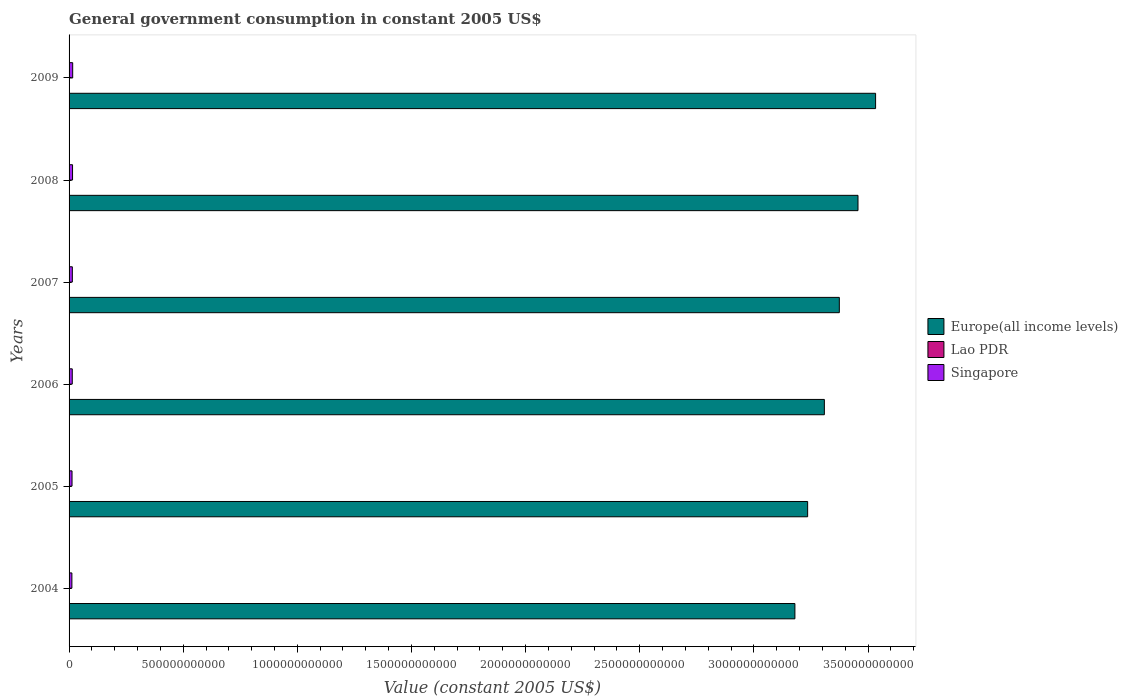Are the number of bars per tick equal to the number of legend labels?
Give a very brief answer. Yes. How many bars are there on the 2nd tick from the top?
Your answer should be compact. 3. What is the label of the 3rd group of bars from the top?
Offer a very short reply. 2007. What is the government conusmption in Europe(all income levels) in 2005?
Offer a terse response. 3.24e+12. Across all years, what is the maximum government conusmption in Europe(all income levels)?
Give a very brief answer. 3.53e+12. Across all years, what is the minimum government conusmption in Lao PDR?
Keep it short and to the point. 1.79e+08. What is the total government conusmption in Singapore in the graph?
Offer a terse response. 8.48e+1. What is the difference between the government conusmption in Lao PDR in 2008 and that in 2009?
Keep it short and to the point. -7.29e+07. What is the difference between the government conusmption in Lao PDR in 2006 and the government conusmption in Europe(all income levels) in 2009?
Your answer should be compact. -3.53e+12. What is the average government conusmption in Europe(all income levels) per year?
Ensure brevity in your answer.  3.35e+12. In the year 2004, what is the difference between the government conusmption in Europe(all income levels) and government conusmption in Lao PDR?
Your response must be concise. 3.18e+12. What is the ratio of the government conusmption in Lao PDR in 2005 to that in 2008?
Your answer should be compact. 0.68. What is the difference between the highest and the second highest government conusmption in Lao PDR?
Keep it short and to the point. 7.29e+07. What is the difference between the highest and the lowest government conusmption in Europe(all income levels)?
Keep it short and to the point. 3.53e+11. In how many years, is the government conusmption in Singapore greater than the average government conusmption in Singapore taken over all years?
Offer a very short reply. 3. Is the sum of the government conusmption in Europe(all income levels) in 2005 and 2006 greater than the maximum government conusmption in Lao PDR across all years?
Your response must be concise. Yes. What does the 2nd bar from the top in 2008 represents?
Your answer should be compact. Lao PDR. What does the 1st bar from the bottom in 2005 represents?
Make the answer very short. Europe(all income levels). Is it the case that in every year, the sum of the government conusmption in Singapore and government conusmption in Europe(all income levels) is greater than the government conusmption in Lao PDR?
Offer a terse response. Yes. How many bars are there?
Offer a very short reply. 18. What is the difference between two consecutive major ticks on the X-axis?
Give a very brief answer. 5.00e+11. Are the values on the major ticks of X-axis written in scientific E-notation?
Ensure brevity in your answer.  No. Where does the legend appear in the graph?
Provide a short and direct response. Center right. What is the title of the graph?
Provide a succinct answer. General government consumption in constant 2005 US$. Does "Croatia" appear as one of the legend labels in the graph?
Provide a short and direct response. No. What is the label or title of the X-axis?
Ensure brevity in your answer.  Value (constant 2005 US$). What is the label or title of the Y-axis?
Offer a terse response. Years. What is the Value (constant 2005 US$) of Europe(all income levels) in 2004?
Keep it short and to the point. 3.18e+12. What is the Value (constant 2005 US$) of Lao PDR in 2004?
Your answer should be very brief. 1.79e+08. What is the Value (constant 2005 US$) of Singapore in 2004?
Offer a terse response. 1.24e+1. What is the Value (constant 2005 US$) in Europe(all income levels) in 2005?
Provide a succinct answer. 3.24e+12. What is the Value (constant 2005 US$) in Lao PDR in 2005?
Your response must be concise. 2.22e+08. What is the Value (constant 2005 US$) in Singapore in 2005?
Provide a short and direct response. 1.30e+1. What is the Value (constant 2005 US$) of Europe(all income levels) in 2006?
Your response must be concise. 3.31e+12. What is the Value (constant 2005 US$) of Lao PDR in 2006?
Your answer should be very brief. 2.48e+08. What is the Value (constant 2005 US$) of Singapore in 2006?
Ensure brevity in your answer.  1.40e+1. What is the Value (constant 2005 US$) in Europe(all income levels) in 2007?
Your answer should be compact. 3.37e+12. What is the Value (constant 2005 US$) in Lao PDR in 2007?
Your answer should be very brief. 2.70e+08. What is the Value (constant 2005 US$) in Singapore in 2007?
Offer a very short reply. 1.44e+1. What is the Value (constant 2005 US$) in Europe(all income levels) in 2008?
Provide a succinct answer. 3.46e+12. What is the Value (constant 2005 US$) of Lao PDR in 2008?
Provide a succinct answer. 3.25e+08. What is the Value (constant 2005 US$) of Singapore in 2008?
Keep it short and to the point. 1.52e+1. What is the Value (constant 2005 US$) of Europe(all income levels) in 2009?
Your answer should be compact. 3.53e+12. What is the Value (constant 2005 US$) of Lao PDR in 2009?
Offer a very short reply. 3.98e+08. What is the Value (constant 2005 US$) of Singapore in 2009?
Ensure brevity in your answer.  1.59e+1. Across all years, what is the maximum Value (constant 2005 US$) of Europe(all income levels)?
Ensure brevity in your answer.  3.53e+12. Across all years, what is the maximum Value (constant 2005 US$) in Lao PDR?
Make the answer very short. 3.98e+08. Across all years, what is the maximum Value (constant 2005 US$) in Singapore?
Provide a short and direct response. 1.59e+1. Across all years, what is the minimum Value (constant 2005 US$) in Europe(all income levels)?
Keep it short and to the point. 3.18e+12. Across all years, what is the minimum Value (constant 2005 US$) in Lao PDR?
Give a very brief answer. 1.79e+08. Across all years, what is the minimum Value (constant 2005 US$) in Singapore?
Provide a succinct answer. 1.24e+1. What is the total Value (constant 2005 US$) of Europe(all income levels) in the graph?
Give a very brief answer. 2.01e+13. What is the total Value (constant 2005 US$) in Lao PDR in the graph?
Ensure brevity in your answer.  1.64e+09. What is the total Value (constant 2005 US$) in Singapore in the graph?
Make the answer very short. 8.48e+1. What is the difference between the Value (constant 2005 US$) of Europe(all income levels) in 2004 and that in 2005?
Keep it short and to the point. -5.58e+1. What is the difference between the Value (constant 2005 US$) of Lao PDR in 2004 and that in 2005?
Make the answer very short. -4.29e+07. What is the difference between the Value (constant 2005 US$) of Singapore in 2004 and that in 2005?
Ensure brevity in your answer.  -6.22e+08. What is the difference between the Value (constant 2005 US$) in Europe(all income levels) in 2004 and that in 2006?
Make the answer very short. -1.29e+11. What is the difference between the Value (constant 2005 US$) of Lao PDR in 2004 and that in 2006?
Provide a short and direct response. -6.93e+07. What is the difference between the Value (constant 2005 US$) of Singapore in 2004 and that in 2006?
Offer a terse response. -1.63e+09. What is the difference between the Value (constant 2005 US$) in Europe(all income levels) in 2004 and that in 2007?
Provide a succinct answer. -1.95e+11. What is the difference between the Value (constant 2005 US$) of Lao PDR in 2004 and that in 2007?
Provide a succinct answer. -9.17e+07. What is the difference between the Value (constant 2005 US$) in Singapore in 2004 and that in 2007?
Give a very brief answer. -2.01e+09. What is the difference between the Value (constant 2005 US$) of Europe(all income levels) in 2004 and that in 2008?
Your answer should be compact. -2.76e+11. What is the difference between the Value (constant 2005 US$) of Lao PDR in 2004 and that in 2008?
Ensure brevity in your answer.  -1.46e+08. What is the difference between the Value (constant 2005 US$) of Singapore in 2004 and that in 2008?
Make the answer very short. -2.86e+09. What is the difference between the Value (constant 2005 US$) in Europe(all income levels) in 2004 and that in 2009?
Give a very brief answer. -3.53e+11. What is the difference between the Value (constant 2005 US$) of Lao PDR in 2004 and that in 2009?
Make the answer very short. -2.19e+08. What is the difference between the Value (constant 2005 US$) in Singapore in 2004 and that in 2009?
Offer a terse response. -3.50e+09. What is the difference between the Value (constant 2005 US$) of Europe(all income levels) in 2005 and that in 2006?
Make the answer very short. -7.32e+1. What is the difference between the Value (constant 2005 US$) of Lao PDR in 2005 and that in 2006?
Ensure brevity in your answer.  -2.64e+07. What is the difference between the Value (constant 2005 US$) in Singapore in 2005 and that in 2006?
Provide a succinct answer. -1.01e+09. What is the difference between the Value (constant 2005 US$) in Europe(all income levels) in 2005 and that in 2007?
Make the answer very short. -1.39e+11. What is the difference between the Value (constant 2005 US$) of Lao PDR in 2005 and that in 2007?
Keep it short and to the point. -4.88e+07. What is the difference between the Value (constant 2005 US$) in Singapore in 2005 and that in 2007?
Give a very brief answer. -1.39e+09. What is the difference between the Value (constant 2005 US$) of Europe(all income levels) in 2005 and that in 2008?
Give a very brief answer. -2.21e+11. What is the difference between the Value (constant 2005 US$) in Lao PDR in 2005 and that in 2008?
Ensure brevity in your answer.  -1.03e+08. What is the difference between the Value (constant 2005 US$) of Singapore in 2005 and that in 2008?
Provide a short and direct response. -2.24e+09. What is the difference between the Value (constant 2005 US$) in Europe(all income levels) in 2005 and that in 2009?
Your response must be concise. -2.98e+11. What is the difference between the Value (constant 2005 US$) in Lao PDR in 2005 and that in 2009?
Offer a terse response. -1.76e+08. What is the difference between the Value (constant 2005 US$) in Singapore in 2005 and that in 2009?
Provide a succinct answer. -2.88e+09. What is the difference between the Value (constant 2005 US$) of Europe(all income levels) in 2006 and that in 2007?
Your answer should be very brief. -6.56e+1. What is the difference between the Value (constant 2005 US$) in Lao PDR in 2006 and that in 2007?
Ensure brevity in your answer.  -2.24e+07. What is the difference between the Value (constant 2005 US$) of Singapore in 2006 and that in 2007?
Your answer should be very brief. -3.81e+08. What is the difference between the Value (constant 2005 US$) in Europe(all income levels) in 2006 and that in 2008?
Offer a terse response. -1.47e+11. What is the difference between the Value (constant 2005 US$) of Lao PDR in 2006 and that in 2008?
Your answer should be very brief. -7.70e+07. What is the difference between the Value (constant 2005 US$) of Singapore in 2006 and that in 2008?
Provide a short and direct response. -1.23e+09. What is the difference between the Value (constant 2005 US$) of Europe(all income levels) in 2006 and that in 2009?
Offer a very short reply. -2.24e+11. What is the difference between the Value (constant 2005 US$) in Lao PDR in 2006 and that in 2009?
Offer a terse response. -1.50e+08. What is the difference between the Value (constant 2005 US$) in Singapore in 2006 and that in 2009?
Give a very brief answer. -1.87e+09. What is the difference between the Value (constant 2005 US$) of Europe(all income levels) in 2007 and that in 2008?
Your answer should be very brief. -8.17e+1. What is the difference between the Value (constant 2005 US$) in Lao PDR in 2007 and that in 2008?
Your answer should be very brief. -5.46e+07. What is the difference between the Value (constant 2005 US$) of Singapore in 2007 and that in 2008?
Ensure brevity in your answer.  -8.50e+08. What is the difference between the Value (constant 2005 US$) of Europe(all income levels) in 2007 and that in 2009?
Your answer should be very brief. -1.59e+11. What is the difference between the Value (constant 2005 US$) of Lao PDR in 2007 and that in 2009?
Keep it short and to the point. -1.27e+08. What is the difference between the Value (constant 2005 US$) in Singapore in 2007 and that in 2009?
Provide a succinct answer. -1.48e+09. What is the difference between the Value (constant 2005 US$) in Europe(all income levels) in 2008 and that in 2009?
Your response must be concise. -7.71e+1. What is the difference between the Value (constant 2005 US$) in Lao PDR in 2008 and that in 2009?
Offer a terse response. -7.29e+07. What is the difference between the Value (constant 2005 US$) in Singapore in 2008 and that in 2009?
Ensure brevity in your answer.  -6.35e+08. What is the difference between the Value (constant 2005 US$) of Europe(all income levels) in 2004 and the Value (constant 2005 US$) of Lao PDR in 2005?
Provide a short and direct response. 3.18e+12. What is the difference between the Value (constant 2005 US$) in Europe(all income levels) in 2004 and the Value (constant 2005 US$) in Singapore in 2005?
Offer a terse response. 3.17e+12. What is the difference between the Value (constant 2005 US$) of Lao PDR in 2004 and the Value (constant 2005 US$) of Singapore in 2005?
Ensure brevity in your answer.  -1.28e+1. What is the difference between the Value (constant 2005 US$) of Europe(all income levels) in 2004 and the Value (constant 2005 US$) of Lao PDR in 2006?
Ensure brevity in your answer.  3.18e+12. What is the difference between the Value (constant 2005 US$) in Europe(all income levels) in 2004 and the Value (constant 2005 US$) in Singapore in 2006?
Your answer should be compact. 3.17e+12. What is the difference between the Value (constant 2005 US$) in Lao PDR in 2004 and the Value (constant 2005 US$) in Singapore in 2006?
Offer a very short reply. -1.38e+1. What is the difference between the Value (constant 2005 US$) in Europe(all income levels) in 2004 and the Value (constant 2005 US$) in Lao PDR in 2007?
Your answer should be very brief. 3.18e+12. What is the difference between the Value (constant 2005 US$) in Europe(all income levels) in 2004 and the Value (constant 2005 US$) in Singapore in 2007?
Keep it short and to the point. 3.17e+12. What is the difference between the Value (constant 2005 US$) of Lao PDR in 2004 and the Value (constant 2005 US$) of Singapore in 2007?
Give a very brief answer. -1.42e+1. What is the difference between the Value (constant 2005 US$) of Europe(all income levels) in 2004 and the Value (constant 2005 US$) of Lao PDR in 2008?
Offer a terse response. 3.18e+12. What is the difference between the Value (constant 2005 US$) of Europe(all income levels) in 2004 and the Value (constant 2005 US$) of Singapore in 2008?
Ensure brevity in your answer.  3.16e+12. What is the difference between the Value (constant 2005 US$) of Lao PDR in 2004 and the Value (constant 2005 US$) of Singapore in 2008?
Your response must be concise. -1.50e+1. What is the difference between the Value (constant 2005 US$) of Europe(all income levels) in 2004 and the Value (constant 2005 US$) of Lao PDR in 2009?
Give a very brief answer. 3.18e+12. What is the difference between the Value (constant 2005 US$) of Europe(all income levels) in 2004 and the Value (constant 2005 US$) of Singapore in 2009?
Make the answer very short. 3.16e+12. What is the difference between the Value (constant 2005 US$) in Lao PDR in 2004 and the Value (constant 2005 US$) in Singapore in 2009?
Your answer should be very brief. -1.57e+1. What is the difference between the Value (constant 2005 US$) of Europe(all income levels) in 2005 and the Value (constant 2005 US$) of Lao PDR in 2006?
Keep it short and to the point. 3.24e+12. What is the difference between the Value (constant 2005 US$) in Europe(all income levels) in 2005 and the Value (constant 2005 US$) in Singapore in 2006?
Provide a succinct answer. 3.22e+12. What is the difference between the Value (constant 2005 US$) of Lao PDR in 2005 and the Value (constant 2005 US$) of Singapore in 2006?
Keep it short and to the point. -1.38e+1. What is the difference between the Value (constant 2005 US$) of Europe(all income levels) in 2005 and the Value (constant 2005 US$) of Lao PDR in 2007?
Your answer should be compact. 3.24e+12. What is the difference between the Value (constant 2005 US$) of Europe(all income levels) in 2005 and the Value (constant 2005 US$) of Singapore in 2007?
Ensure brevity in your answer.  3.22e+12. What is the difference between the Value (constant 2005 US$) of Lao PDR in 2005 and the Value (constant 2005 US$) of Singapore in 2007?
Your answer should be compact. -1.41e+1. What is the difference between the Value (constant 2005 US$) in Europe(all income levels) in 2005 and the Value (constant 2005 US$) in Lao PDR in 2008?
Offer a very short reply. 3.24e+12. What is the difference between the Value (constant 2005 US$) of Europe(all income levels) in 2005 and the Value (constant 2005 US$) of Singapore in 2008?
Your answer should be very brief. 3.22e+12. What is the difference between the Value (constant 2005 US$) of Lao PDR in 2005 and the Value (constant 2005 US$) of Singapore in 2008?
Offer a very short reply. -1.50e+1. What is the difference between the Value (constant 2005 US$) in Europe(all income levels) in 2005 and the Value (constant 2005 US$) in Lao PDR in 2009?
Give a very brief answer. 3.24e+12. What is the difference between the Value (constant 2005 US$) of Europe(all income levels) in 2005 and the Value (constant 2005 US$) of Singapore in 2009?
Give a very brief answer. 3.22e+12. What is the difference between the Value (constant 2005 US$) of Lao PDR in 2005 and the Value (constant 2005 US$) of Singapore in 2009?
Provide a succinct answer. -1.56e+1. What is the difference between the Value (constant 2005 US$) of Europe(all income levels) in 2006 and the Value (constant 2005 US$) of Lao PDR in 2007?
Your answer should be compact. 3.31e+12. What is the difference between the Value (constant 2005 US$) in Europe(all income levels) in 2006 and the Value (constant 2005 US$) in Singapore in 2007?
Offer a very short reply. 3.29e+12. What is the difference between the Value (constant 2005 US$) in Lao PDR in 2006 and the Value (constant 2005 US$) in Singapore in 2007?
Your answer should be very brief. -1.41e+1. What is the difference between the Value (constant 2005 US$) of Europe(all income levels) in 2006 and the Value (constant 2005 US$) of Lao PDR in 2008?
Offer a very short reply. 3.31e+12. What is the difference between the Value (constant 2005 US$) of Europe(all income levels) in 2006 and the Value (constant 2005 US$) of Singapore in 2008?
Make the answer very short. 3.29e+12. What is the difference between the Value (constant 2005 US$) in Lao PDR in 2006 and the Value (constant 2005 US$) in Singapore in 2008?
Ensure brevity in your answer.  -1.50e+1. What is the difference between the Value (constant 2005 US$) of Europe(all income levels) in 2006 and the Value (constant 2005 US$) of Lao PDR in 2009?
Offer a terse response. 3.31e+12. What is the difference between the Value (constant 2005 US$) in Europe(all income levels) in 2006 and the Value (constant 2005 US$) in Singapore in 2009?
Make the answer very short. 3.29e+12. What is the difference between the Value (constant 2005 US$) of Lao PDR in 2006 and the Value (constant 2005 US$) of Singapore in 2009?
Ensure brevity in your answer.  -1.56e+1. What is the difference between the Value (constant 2005 US$) of Europe(all income levels) in 2007 and the Value (constant 2005 US$) of Lao PDR in 2008?
Make the answer very short. 3.37e+12. What is the difference between the Value (constant 2005 US$) of Europe(all income levels) in 2007 and the Value (constant 2005 US$) of Singapore in 2008?
Offer a terse response. 3.36e+12. What is the difference between the Value (constant 2005 US$) of Lao PDR in 2007 and the Value (constant 2005 US$) of Singapore in 2008?
Your answer should be very brief. -1.49e+1. What is the difference between the Value (constant 2005 US$) of Europe(all income levels) in 2007 and the Value (constant 2005 US$) of Lao PDR in 2009?
Keep it short and to the point. 3.37e+12. What is the difference between the Value (constant 2005 US$) in Europe(all income levels) in 2007 and the Value (constant 2005 US$) in Singapore in 2009?
Provide a succinct answer. 3.36e+12. What is the difference between the Value (constant 2005 US$) of Lao PDR in 2007 and the Value (constant 2005 US$) of Singapore in 2009?
Provide a short and direct response. -1.56e+1. What is the difference between the Value (constant 2005 US$) of Europe(all income levels) in 2008 and the Value (constant 2005 US$) of Lao PDR in 2009?
Ensure brevity in your answer.  3.46e+12. What is the difference between the Value (constant 2005 US$) of Europe(all income levels) in 2008 and the Value (constant 2005 US$) of Singapore in 2009?
Make the answer very short. 3.44e+12. What is the difference between the Value (constant 2005 US$) of Lao PDR in 2008 and the Value (constant 2005 US$) of Singapore in 2009?
Keep it short and to the point. -1.55e+1. What is the average Value (constant 2005 US$) in Europe(all income levels) per year?
Make the answer very short. 3.35e+12. What is the average Value (constant 2005 US$) in Lao PDR per year?
Give a very brief answer. 2.74e+08. What is the average Value (constant 2005 US$) of Singapore per year?
Provide a short and direct response. 1.41e+1. In the year 2004, what is the difference between the Value (constant 2005 US$) in Europe(all income levels) and Value (constant 2005 US$) in Lao PDR?
Your answer should be compact. 3.18e+12. In the year 2004, what is the difference between the Value (constant 2005 US$) of Europe(all income levels) and Value (constant 2005 US$) of Singapore?
Give a very brief answer. 3.17e+12. In the year 2004, what is the difference between the Value (constant 2005 US$) of Lao PDR and Value (constant 2005 US$) of Singapore?
Ensure brevity in your answer.  -1.22e+1. In the year 2005, what is the difference between the Value (constant 2005 US$) of Europe(all income levels) and Value (constant 2005 US$) of Lao PDR?
Your answer should be compact. 3.24e+12. In the year 2005, what is the difference between the Value (constant 2005 US$) of Europe(all income levels) and Value (constant 2005 US$) of Singapore?
Keep it short and to the point. 3.22e+12. In the year 2005, what is the difference between the Value (constant 2005 US$) of Lao PDR and Value (constant 2005 US$) of Singapore?
Offer a very short reply. -1.28e+1. In the year 2006, what is the difference between the Value (constant 2005 US$) in Europe(all income levels) and Value (constant 2005 US$) in Lao PDR?
Give a very brief answer. 3.31e+12. In the year 2006, what is the difference between the Value (constant 2005 US$) of Europe(all income levels) and Value (constant 2005 US$) of Singapore?
Keep it short and to the point. 3.29e+12. In the year 2006, what is the difference between the Value (constant 2005 US$) in Lao PDR and Value (constant 2005 US$) in Singapore?
Make the answer very short. -1.37e+1. In the year 2007, what is the difference between the Value (constant 2005 US$) in Europe(all income levels) and Value (constant 2005 US$) in Lao PDR?
Your response must be concise. 3.37e+12. In the year 2007, what is the difference between the Value (constant 2005 US$) of Europe(all income levels) and Value (constant 2005 US$) of Singapore?
Offer a very short reply. 3.36e+12. In the year 2007, what is the difference between the Value (constant 2005 US$) in Lao PDR and Value (constant 2005 US$) in Singapore?
Give a very brief answer. -1.41e+1. In the year 2008, what is the difference between the Value (constant 2005 US$) in Europe(all income levels) and Value (constant 2005 US$) in Lao PDR?
Offer a very short reply. 3.46e+12. In the year 2008, what is the difference between the Value (constant 2005 US$) of Europe(all income levels) and Value (constant 2005 US$) of Singapore?
Make the answer very short. 3.44e+12. In the year 2008, what is the difference between the Value (constant 2005 US$) in Lao PDR and Value (constant 2005 US$) in Singapore?
Offer a very short reply. -1.49e+1. In the year 2009, what is the difference between the Value (constant 2005 US$) of Europe(all income levels) and Value (constant 2005 US$) of Lao PDR?
Keep it short and to the point. 3.53e+12. In the year 2009, what is the difference between the Value (constant 2005 US$) in Europe(all income levels) and Value (constant 2005 US$) in Singapore?
Make the answer very short. 3.52e+12. In the year 2009, what is the difference between the Value (constant 2005 US$) of Lao PDR and Value (constant 2005 US$) of Singapore?
Keep it short and to the point. -1.55e+1. What is the ratio of the Value (constant 2005 US$) in Europe(all income levels) in 2004 to that in 2005?
Give a very brief answer. 0.98. What is the ratio of the Value (constant 2005 US$) in Lao PDR in 2004 to that in 2005?
Your answer should be very brief. 0.81. What is the ratio of the Value (constant 2005 US$) in Singapore in 2004 to that in 2005?
Provide a short and direct response. 0.95. What is the ratio of the Value (constant 2005 US$) in Europe(all income levels) in 2004 to that in 2006?
Offer a very short reply. 0.96. What is the ratio of the Value (constant 2005 US$) in Lao PDR in 2004 to that in 2006?
Offer a terse response. 0.72. What is the ratio of the Value (constant 2005 US$) of Singapore in 2004 to that in 2006?
Provide a short and direct response. 0.88. What is the ratio of the Value (constant 2005 US$) of Europe(all income levels) in 2004 to that in 2007?
Your answer should be compact. 0.94. What is the ratio of the Value (constant 2005 US$) in Lao PDR in 2004 to that in 2007?
Offer a very short reply. 0.66. What is the ratio of the Value (constant 2005 US$) in Singapore in 2004 to that in 2007?
Offer a terse response. 0.86. What is the ratio of the Value (constant 2005 US$) of Europe(all income levels) in 2004 to that in 2008?
Give a very brief answer. 0.92. What is the ratio of the Value (constant 2005 US$) in Lao PDR in 2004 to that in 2008?
Your response must be concise. 0.55. What is the ratio of the Value (constant 2005 US$) in Singapore in 2004 to that in 2008?
Provide a succinct answer. 0.81. What is the ratio of the Value (constant 2005 US$) of Europe(all income levels) in 2004 to that in 2009?
Offer a terse response. 0.9. What is the ratio of the Value (constant 2005 US$) of Lao PDR in 2004 to that in 2009?
Keep it short and to the point. 0.45. What is the ratio of the Value (constant 2005 US$) in Singapore in 2004 to that in 2009?
Provide a succinct answer. 0.78. What is the ratio of the Value (constant 2005 US$) of Europe(all income levels) in 2005 to that in 2006?
Make the answer very short. 0.98. What is the ratio of the Value (constant 2005 US$) in Lao PDR in 2005 to that in 2006?
Your answer should be very brief. 0.89. What is the ratio of the Value (constant 2005 US$) in Singapore in 2005 to that in 2006?
Keep it short and to the point. 0.93. What is the ratio of the Value (constant 2005 US$) in Europe(all income levels) in 2005 to that in 2007?
Give a very brief answer. 0.96. What is the ratio of the Value (constant 2005 US$) of Lao PDR in 2005 to that in 2007?
Give a very brief answer. 0.82. What is the ratio of the Value (constant 2005 US$) in Singapore in 2005 to that in 2007?
Ensure brevity in your answer.  0.9. What is the ratio of the Value (constant 2005 US$) of Europe(all income levels) in 2005 to that in 2008?
Give a very brief answer. 0.94. What is the ratio of the Value (constant 2005 US$) of Lao PDR in 2005 to that in 2008?
Offer a terse response. 0.68. What is the ratio of the Value (constant 2005 US$) in Singapore in 2005 to that in 2008?
Your answer should be compact. 0.85. What is the ratio of the Value (constant 2005 US$) in Europe(all income levels) in 2005 to that in 2009?
Make the answer very short. 0.92. What is the ratio of the Value (constant 2005 US$) of Lao PDR in 2005 to that in 2009?
Provide a succinct answer. 0.56. What is the ratio of the Value (constant 2005 US$) in Singapore in 2005 to that in 2009?
Offer a very short reply. 0.82. What is the ratio of the Value (constant 2005 US$) of Europe(all income levels) in 2006 to that in 2007?
Your response must be concise. 0.98. What is the ratio of the Value (constant 2005 US$) of Lao PDR in 2006 to that in 2007?
Keep it short and to the point. 0.92. What is the ratio of the Value (constant 2005 US$) of Singapore in 2006 to that in 2007?
Your answer should be compact. 0.97. What is the ratio of the Value (constant 2005 US$) in Europe(all income levels) in 2006 to that in 2008?
Ensure brevity in your answer.  0.96. What is the ratio of the Value (constant 2005 US$) of Lao PDR in 2006 to that in 2008?
Your response must be concise. 0.76. What is the ratio of the Value (constant 2005 US$) of Singapore in 2006 to that in 2008?
Your response must be concise. 0.92. What is the ratio of the Value (constant 2005 US$) of Europe(all income levels) in 2006 to that in 2009?
Make the answer very short. 0.94. What is the ratio of the Value (constant 2005 US$) in Lao PDR in 2006 to that in 2009?
Provide a short and direct response. 0.62. What is the ratio of the Value (constant 2005 US$) of Singapore in 2006 to that in 2009?
Provide a short and direct response. 0.88. What is the ratio of the Value (constant 2005 US$) of Europe(all income levels) in 2007 to that in 2008?
Offer a terse response. 0.98. What is the ratio of the Value (constant 2005 US$) in Lao PDR in 2007 to that in 2008?
Your answer should be very brief. 0.83. What is the ratio of the Value (constant 2005 US$) of Singapore in 2007 to that in 2008?
Your answer should be compact. 0.94. What is the ratio of the Value (constant 2005 US$) in Europe(all income levels) in 2007 to that in 2009?
Your response must be concise. 0.95. What is the ratio of the Value (constant 2005 US$) of Lao PDR in 2007 to that in 2009?
Provide a short and direct response. 0.68. What is the ratio of the Value (constant 2005 US$) in Singapore in 2007 to that in 2009?
Your answer should be very brief. 0.91. What is the ratio of the Value (constant 2005 US$) in Europe(all income levels) in 2008 to that in 2009?
Your response must be concise. 0.98. What is the ratio of the Value (constant 2005 US$) of Lao PDR in 2008 to that in 2009?
Your answer should be compact. 0.82. What is the ratio of the Value (constant 2005 US$) in Singapore in 2008 to that in 2009?
Offer a terse response. 0.96. What is the difference between the highest and the second highest Value (constant 2005 US$) in Europe(all income levels)?
Provide a short and direct response. 7.71e+1. What is the difference between the highest and the second highest Value (constant 2005 US$) in Lao PDR?
Your answer should be compact. 7.29e+07. What is the difference between the highest and the second highest Value (constant 2005 US$) in Singapore?
Ensure brevity in your answer.  6.35e+08. What is the difference between the highest and the lowest Value (constant 2005 US$) of Europe(all income levels)?
Offer a terse response. 3.53e+11. What is the difference between the highest and the lowest Value (constant 2005 US$) of Lao PDR?
Give a very brief answer. 2.19e+08. What is the difference between the highest and the lowest Value (constant 2005 US$) in Singapore?
Make the answer very short. 3.50e+09. 